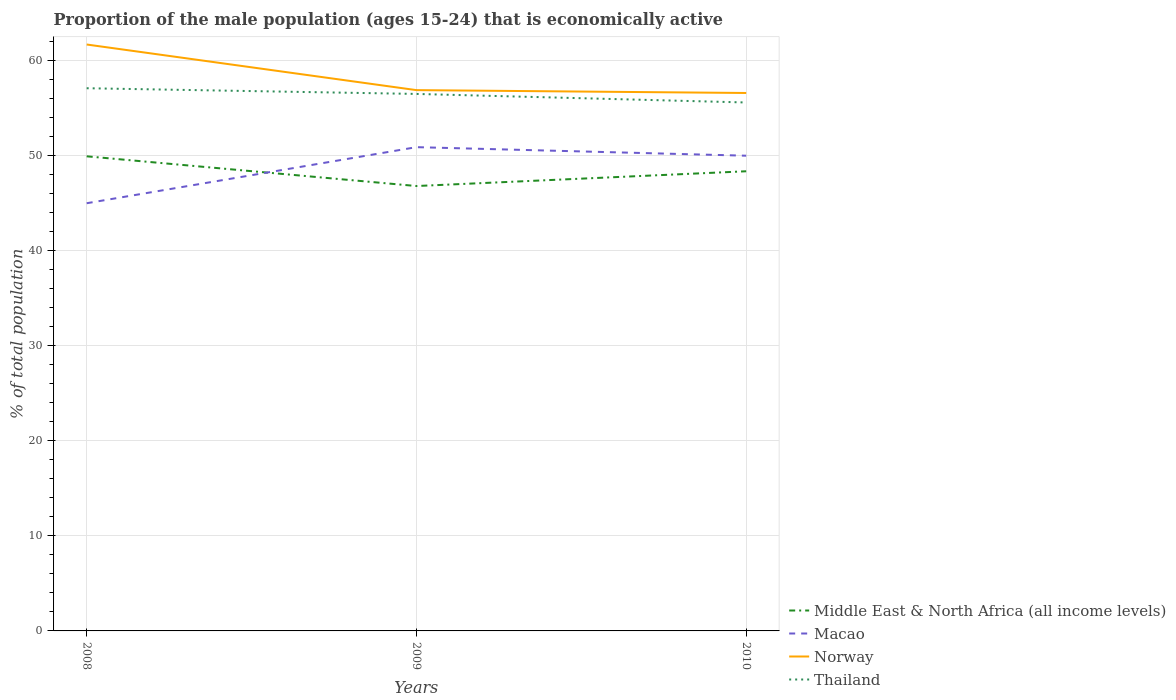Does the line corresponding to Macao intersect with the line corresponding to Middle East & North Africa (all income levels)?
Offer a very short reply. Yes. Is the number of lines equal to the number of legend labels?
Give a very brief answer. Yes. Across all years, what is the maximum proportion of the male population that is economically active in Thailand?
Ensure brevity in your answer.  55.6. What is the total proportion of the male population that is economically active in Thailand in the graph?
Provide a succinct answer. 0.6. What is the difference between the highest and the second highest proportion of the male population that is economically active in Thailand?
Offer a terse response. 1.5. Is the proportion of the male population that is economically active in Middle East & North Africa (all income levels) strictly greater than the proportion of the male population that is economically active in Thailand over the years?
Offer a terse response. Yes. How many lines are there?
Your answer should be compact. 4. How many years are there in the graph?
Keep it short and to the point. 3. What is the difference between two consecutive major ticks on the Y-axis?
Your response must be concise. 10. Does the graph contain grids?
Provide a succinct answer. Yes. How are the legend labels stacked?
Give a very brief answer. Vertical. What is the title of the graph?
Provide a short and direct response. Proportion of the male population (ages 15-24) that is economically active. Does "Czech Republic" appear as one of the legend labels in the graph?
Provide a succinct answer. No. What is the label or title of the Y-axis?
Provide a short and direct response. % of total population. What is the % of total population in Middle East & North Africa (all income levels) in 2008?
Make the answer very short. 49.94. What is the % of total population of Macao in 2008?
Your answer should be compact. 45. What is the % of total population in Norway in 2008?
Provide a short and direct response. 61.7. What is the % of total population in Thailand in 2008?
Provide a succinct answer. 57.1. What is the % of total population of Middle East & North Africa (all income levels) in 2009?
Your answer should be very brief. 46.81. What is the % of total population of Macao in 2009?
Offer a very short reply. 50.9. What is the % of total population in Norway in 2009?
Offer a terse response. 56.9. What is the % of total population in Thailand in 2009?
Your response must be concise. 56.5. What is the % of total population of Middle East & North Africa (all income levels) in 2010?
Your answer should be compact. 48.36. What is the % of total population of Norway in 2010?
Your response must be concise. 56.6. What is the % of total population of Thailand in 2010?
Make the answer very short. 55.6. Across all years, what is the maximum % of total population of Middle East & North Africa (all income levels)?
Offer a very short reply. 49.94. Across all years, what is the maximum % of total population of Macao?
Offer a terse response. 50.9. Across all years, what is the maximum % of total population in Norway?
Offer a very short reply. 61.7. Across all years, what is the maximum % of total population of Thailand?
Your answer should be very brief. 57.1. Across all years, what is the minimum % of total population of Middle East & North Africa (all income levels)?
Give a very brief answer. 46.81. Across all years, what is the minimum % of total population in Norway?
Offer a very short reply. 56.6. Across all years, what is the minimum % of total population in Thailand?
Your answer should be compact. 55.6. What is the total % of total population in Middle East & North Africa (all income levels) in the graph?
Ensure brevity in your answer.  145.11. What is the total % of total population of Macao in the graph?
Offer a terse response. 145.9. What is the total % of total population in Norway in the graph?
Ensure brevity in your answer.  175.2. What is the total % of total population of Thailand in the graph?
Provide a succinct answer. 169.2. What is the difference between the % of total population in Middle East & North Africa (all income levels) in 2008 and that in 2009?
Your answer should be very brief. 3.13. What is the difference between the % of total population of Macao in 2008 and that in 2009?
Provide a succinct answer. -5.9. What is the difference between the % of total population of Norway in 2008 and that in 2009?
Offer a terse response. 4.8. What is the difference between the % of total population in Thailand in 2008 and that in 2009?
Offer a very short reply. 0.6. What is the difference between the % of total population of Middle East & North Africa (all income levels) in 2008 and that in 2010?
Your response must be concise. 1.57. What is the difference between the % of total population of Macao in 2008 and that in 2010?
Your response must be concise. -5. What is the difference between the % of total population in Norway in 2008 and that in 2010?
Your answer should be compact. 5.1. What is the difference between the % of total population in Thailand in 2008 and that in 2010?
Keep it short and to the point. 1.5. What is the difference between the % of total population of Middle East & North Africa (all income levels) in 2009 and that in 2010?
Keep it short and to the point. -1.55. What is the difference between the % of total population of Macao in 2009 and that in 2010?
Provide a succinct answer. 0.9. What is the difference between the % of total population in Norway in 2009 and that in 2010?
Your response must be concise. 0.3. What is the difference between the % of total population in Middle East & North Africa (all income levels) in 2008 and the % of total population in Macao in 2009?
Offer a terse response. -0.96. What is the difference between the % of total population in Middle East & North Africa (all income levels) in 2008 and the % of total population in Norway in 2009?
Provide a short and direct response. -6.96. What is the difference between the % of total population of Middle East & North Africa (all income levels) in 2008 and the % of total population of Thailand in 2009?
Your answer should be compact. -6.56. What is the difference between the % of total population in Macao in 2008 and the % of total population in Norway in 2009?
Your answer should be very brief. -11.9. What is the difference between the % of total population in Macao in 2008 and the % of total population in Thailand in 2009?
Provide a short and direct response. -11.5. What is the difference between the % of total population in Norway in 2008 and the % of total population in Thailand in 2009?
Your answer should be very brief. 5.2. What is the difference between the % of total population in Middle East & North Africa (all income levels) in 2008 and the % of total population in Macao in 2010?
Your response must be concise. -0.06. What is the difference between the % of total population of Middle East & North Africa (all income levels) in 2008 and the % of total population of Norway in 2010?
Provide a short and direct response. -6.66. What is the difference between the % of total population in Middle East & North Africa (all income levels) in 2008 and the % of total population in Thailand in 2010?
Provide a succinct answer. -5.66. What is the difference between the % of total population of Macao in 2008 and the % of total population of Norway in 2010?
Ensure brevity in your answer.  -11.6. What is the difference between the % of total population of Middle East & North Africa (all income levels) in 2009 and the % of total population of Macao in 2010?
Keep it short and to the point. -3.19. What is the difference between the % of total population of Middle East & North Africa (all income levels) in 2009 and the % of total population of Norway in 2010?
Provide a short and direct response. -9.79. What is the difference between the % of total population in Middle East & North Africa (all income levels) in 2009 and the % of total population in Thailand in 2010?
Offer a terse response. -8.79. What is the difference between the % of total population of Macao in 2009 and the % of total population of Norway in 2010?
Keep it short and to the point. -5.7. What is the difference between the % of total population in Macao in 2009 and the % of total population in Thailand in 2010?
Give a very brief answer. -4.7. What is the difference between the % of total population of Norway in 2009 and the % of total population of Thailand in 2010?
Make the answer very short. 1.3. What is the average % of total population of Middle East & North Africa (all income levels) per year?
Give a very brief answer. 48.37. What is the average % of total population of Macao per year?
Offer a terse response. 48.63. What is the average % of total population of Norway per year?
Ensure brevity in your answer.  58.4. What is the average % of total population of Thailand per year?
Offer a very short reply. 56.4. In the year 2008, what is the difference between the % of total population in Middle East & North Africa (all income levels) and % of total population in Macao?
Make the answer very short. 4.94. In the year 2008, what is the difference between the % of total population in Middle East & North Africa (all income levels) and % of total population in Norway?
Offer a terse response. -11.76. In the year 2008, what is the difference between the % of total population in Middle East & North Africa (all income levels) and % of total population in Thailand?
Offer a very short reply. -7.16. In the year 2008, what is the difference between the % of total population of Macao and % of total population of Norway?
Your answer should be compact. -16.7. In the year 2008, what is the difference between the % of total population in Macao and % of total population in Thailand?
Your response must be concise. -12.1. In the year 2009, what is the difference between the % of total population in Middle East & North Africa (all income levels) and % of total population in Macao?
Provide a short and direct response. -4.09. In the year 2009, what is the difference between the % of total population of Middle East & North Africa (all income levels) and % of total population of Norway?
Keep it short and to the point. -10.09. In the year 2009, what is the difference between the % of total population in Middle East & North Africa (all income levels) and % of total population in Thailand?
Offer a very short reply. -9.69. In the year 2009, what is the difference between the % of total population in Macao and % of total population in Thailand?
Your answer should be compact. -5.6. In the year 2009, what is the difference between the % of total population in Norway and % of total population in Thailand?
Offer a terse response. 0.4. In the year 2010, what is the difference between the % of total population of Middle East & North Africa (all income levels) and % of total population of Macao?
Make the answer very short. -1.64. In the year 2010, what is the difference between the % of total population of Middle East & North Africa (all income levels) and % of total population of Norway?
Offer a very short reply. -8.24. In the year 2010, what is the difference between the % of total population in Middle East & North Africa (all income levels) and % of total population in Thailand?
Your answer should be compact. -7.24. In the year 2010, what is the difference between the % of total population in Macao and % of total population in Norway?
Give a very brief answer. -6.6. What is the ratio of the % of total population in Middle East & North Africa (all income levels) in 2008 to that in 2009?
Provide a succinct answer. 1.07. What is the ratio of the % of total population of Macao in 2008 to that in 2009?
Your response must be concise. 0.88. What is the ratio of the % of total population of Norway in 2008 to that in 2009?
Your answer should be very brief. 1.08. What is the ratio of the % of total population of Thailand in 2008 to that in 2009?
Provide a short and direct response. 1.01. What is the ratio of the % of total population in Middle East & North Africa (all income levels) in 2008 to that in 2010?
Offer a terse response. 1.03. What is the ratio of the % of total population in Macao in 2008 to that in 2010?
Offer a very short reply. 0.9. What is the ratio of the % of total population in Norway in 2008 to that in 2010?
Your answer should be very brief. 1.09. What is the ratio of the % of total population in Thailand in 2008 to that in 2010?
Your answer should be compact. 1.03. What is the ratio of the % of total population in Middle East & North Africa (all income levels) in 2009 to that in 2010?
Offer a very short reply. 0.97. What is the ratio of the % of total population of Thailand in 2009 to that in 2010?
Your answer should be compact. 1.02. What is the difference between the highest and the second highest % of total population in Middle East & North Africa (all income levels)?
Offer a terse response. 1.57. What is the difference between the highest and the second highest % of total population of Macao?
Make the answer very short. 0.9. What is the difference between the highest and the second highest % of total population of Norway?
Keep it short and to the point. 4.8. What is the difference between the highest and the lowest % of total population of Middle East & North Africa (all income levels)?
Ensure brevity in your answer.  3.13. What is the difference between the highest and the lowest % of total population in Macao?
Provide a succinct answer. 5.9. What is the difference between the highest and the lowest % of total population in Norway?
Offer a terse response. 5.1. What is the difference between the highest and the lowest % of total population of Thailand?
Your answer should be very brief. 1.5. 